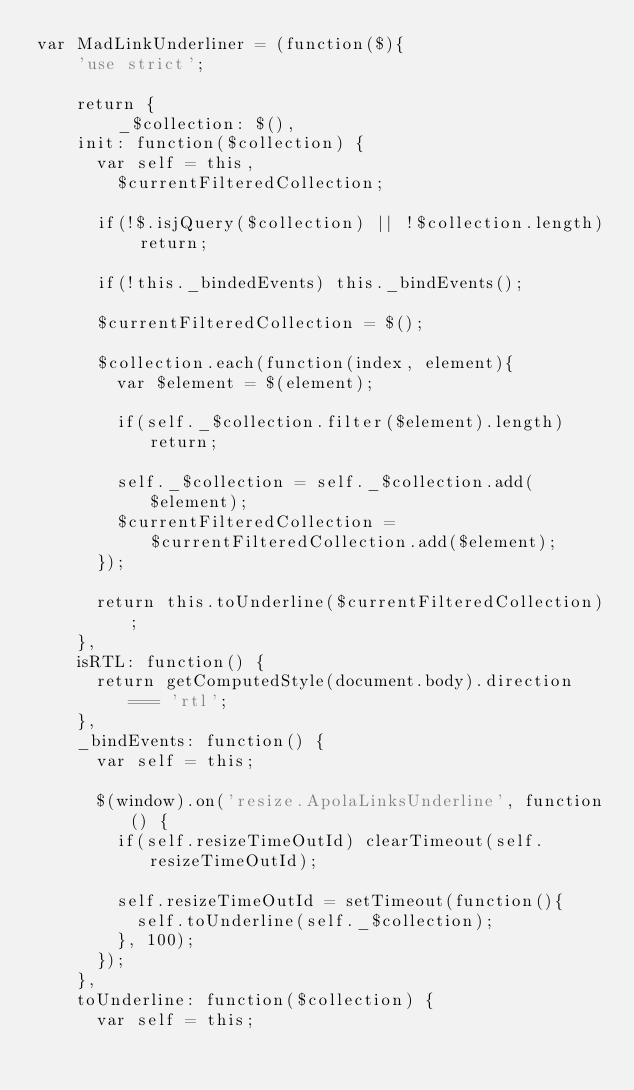Convert code to text. <code><loc_0><loc_0><loc_500><loc_500><_JavaScript_>var MadLinkUnderliner = (function($){
    'use strict';

    return {
        _$collection: $(),
		init: function($collection) {
			var self = this,
				$currentFilteredCollection;

			if(!$.isjQuery($collection) || !$collection.length) return;

			if(!this._bindedEvents) this._bindEvents();

			$currentFilteredCollection = $();

			$collection.each(function(index, element){
				var $element = $(element);

				if(self._$collection.filter($element).length) return;

				self._$collection = self._$collection.add($element);
				$currentFilteredCollection = $currentFilteredCollection.add($element);
			});

			return this.toUnderline($currentFilteredCollection);
		},
		isRTL: function() {
			return getComputedStyle(document.body).direction === 'rtl';
		},
		_bindEvents: function() {
			var self = this;

			$(window).on('resize.ApolaLinksUnderline', function() {
				if(self.resizeTimeOutId) clearTimeout(self.resizeTimeOutId);

				self.resizeTimeOutId = setTimeout(function(){
					self.toUnderline(self._$collection);
				}, 100);
			});
		},
		toUnderline: function($collection) {
			var self = this;
</code> 